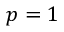Convert formula to latex. <formula><loc_0><loc_0><loc_500><loc_500>p = 1</formula> 